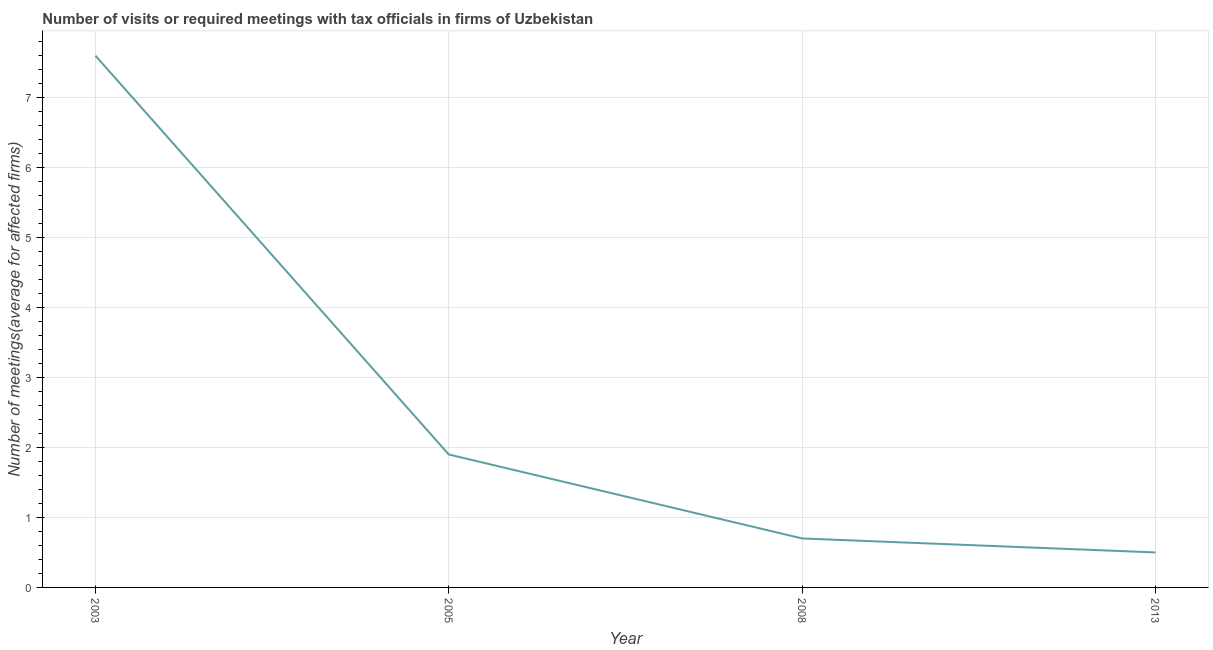Across all years, what is the minimum number of required meetings with tax officials?
Provide a short and direct response. 0.5. What is the sum of the number of required meetings with tax officials?
Provide a short and direct response. 10.7. What is the difference between the number of required meetings with tax officials in 2005 and 2008?
Make the answer very short. 1.2. What is the average number of required meetings with tax officials per year?
Keep it short and to the point. 2.67. What is the median number of required meetings with tax officials?
Your answer should be very brief. 1.3. In how many years, is the number of required meetings with tax officials greater than 2.2 ?
Your answer should be compact. 1. Do a majority of the years between 2003 and 2005 (inclusive) have number of required meetings with tax officials greater than 4.8 ?
Your answer should be very brief. No. What is the ratio of the number of required meetings with tax officials in 2003 to that in 2008?
Keep it short and to the point. 10.86. Is the difference between the number of required meetings with tax officials in 2003 and 2008 greater than the difference between any two years?
Ensure brevity in your answer.  No. What is the difference between the highest and the second highest number of required meetings with tax officials?
Provide a succinct answer. 5.7. Is the sum of the number of required meetings with tax officials in 2003 and 2005 greater than the maximum number of required meetings with tax officials across all years?
Give a very brief answer. Yes. What is the difference between the highest and the lowest number of required meetings with tax officials?
Make the answer very short. 7.1. How many lines are there?
Ensure brevity in your answer.  1. How many years are there in the graph?
Your response must be concise. 4. What is the difference between two consecutive major ticks on the Y-axis?
Keep it short and to the point. 1. Does the graph contain any zero values?
Give a very brief answer. No. What is the title of the graph?
Keep it short and to the point. Number of visits or required meetings with tax officials in firms of Uzbekistan. What is the label or title of the Y-axis?
Make the answer very short. Number of meetings(average for affected firms). What is the Number of meetings(average for affected firms) in 2003?
Your answer should be compact. 7.6. What is the Number of meetings(average for affected firms) of 2005?
Provide a succinct answer. 1.9. What is the difference between the Number of meetings(average for affected firms) in 2003 and 2005?
Keep it short and to the point. 5.7. What is the difference between the Number of meetings(average for affected firms) in 2003 and 2008?
Ensure brevity in your answer.  6.9. What is the difference between the Number of meetings(average for affected firms) in 2003 and 2013?
Your answer should be very brief. 7.1. What is the difference between the Number of meetings(average for affected firms) in 2005 and 2008?
Your answer should be very brief. 1.2. What is the difference between the Number of meetings(average for affected firms) in 2005 and 2013?
Provide a short and direct response. 1.4. What is the difference between the Number of meetings(average for affected firms) in 2008 and 2013?
Your answer should be very brief. 0.2. What is the ratio of the Number of meetings(average for affected firms) in 2003 to that in 2008?
Provide a succinct answer. 10.86. What is the ratio of the Number of meetings(average for affected firms) in 2003 to that in 2013?
Make the answer very short. 15.2. What is the ratio of the Number of meetings(average for affected firms) in 2005 to that in 2008?
Ensure brevity in your answer.  2.71. What is the ratio of the Number of meetings(average for affected firms) in 2005 to that in 2013?
Ensure brevity in your answer.  3.8. What is the ratio of the Number of meetings(average for affected firms) in 2008 to that in 2013?
Give a very brief answer. 1.4. 